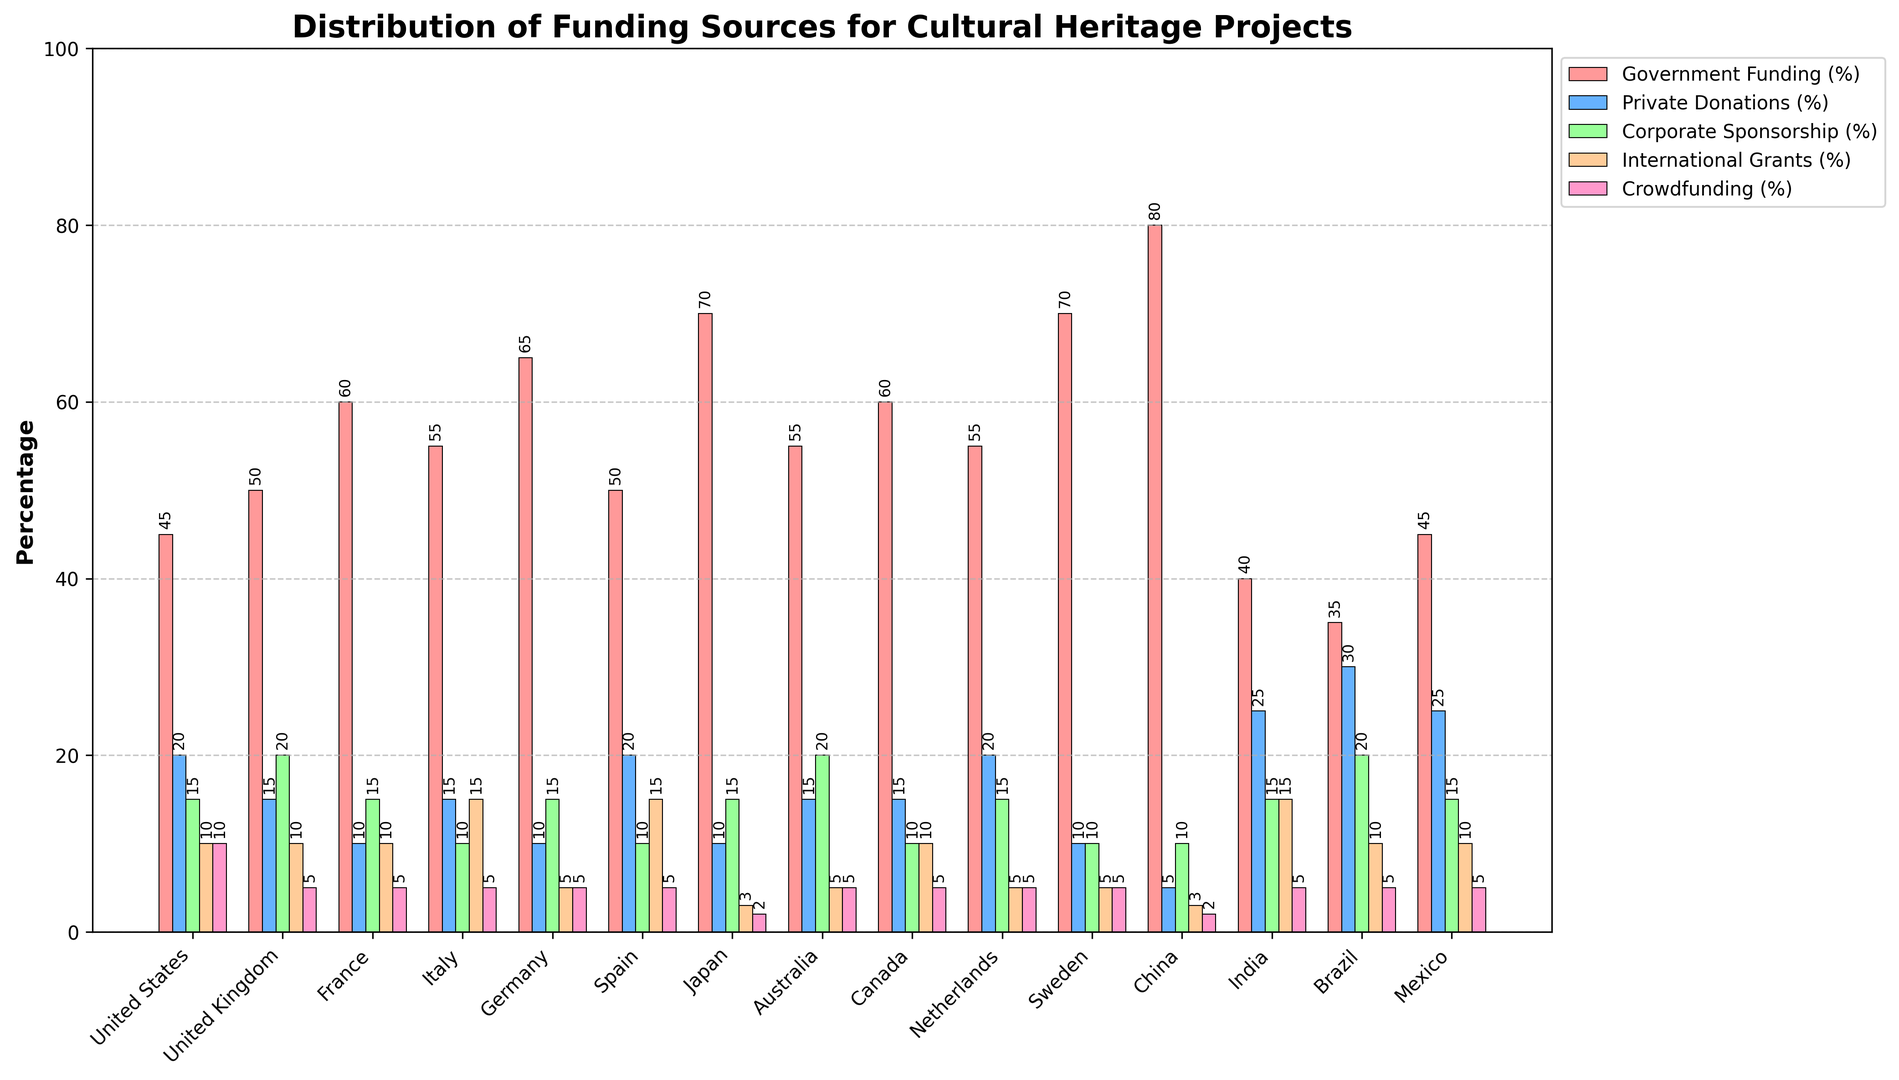What percentage of funding in the United Kingdom comes from government sources? Look at the bar for the United Kingdom and identify the height of the bar corresponding to Government Funding (%)
Answer: 50% How does the percentage of private donations in Brazil compare to that in India? Check the bars for Private Donations (%) in Brazil and India. The height of the bar in Brazil is 30%, and in India, it is 25%. Therefore, Brazil has a higher percentage of private donations compared to India
Answer: Brazil has higher percentage What is the combined percentage of corporate sponsorship in Spain and France? Identify the heights of the Corporate Sponsorship (%) bars for Spain and France, which are 10% and 15% respectively. Adding them gives 10% + 15% = 25%
Answer: 25% Which country receives the highest percentage of government funding? Scan the Government Funding (%) bars for all countries. The highest bar is for China at 80%
Answer: China Do any countries have the same percentage of crowdfunding? If so, which ones? Compare the heights of the Crowdfunding (%) bars for all countries. Several countries have the same percentage of 5%: United Kingdom, France, Italy, Germany, Spain, Australia, Canada, Netherlands, Sweden, India, Brazil, and Mexico
Answer: United Kingdom, France, Italy, Germany, Spain, Australia, Canada, Netherlands, Sweden, India, Brazil, Mexico What is the difference in international grants percentage between Italy and Germany? Look at the International Grants (%) bars for Italy and Germany. Italy has 15% and Germany has 5%, so the difference is 15% - 5% = 10%
Answer: 10% Which country has the lowest percentage of corporate sponsorship and what is the value? Scan the Corporate Sponsorship (%) bars for all countries. The lowest value is found in Italy at 10%
Answer: Italy, 10% How much higher is government funding in Japan compared to the United States? Identify the Government Funding (%) bars for Japan and the United States. Japan has 70%, and the United States has 45%. Therefore, the difference is 70% - 45% = 25%
Answer: 25% What percentage of funding in China comes from international grants? Look at the bar for China and identify the height of the bar corresponding to International Grants (%)
Answer: 3% What is the average percentage of private donations across all countries? Sum the Private Donations (%) for all countries: 20 + 15 + 10 + 15 + 10 + 20 + 10 + 15 + 15 + 20 + 10 + 5 + 25 + 30 + 25 = 235. There are 15 countries, so the average is 235 / 15 = 15.67%
Answer: 15.67% 